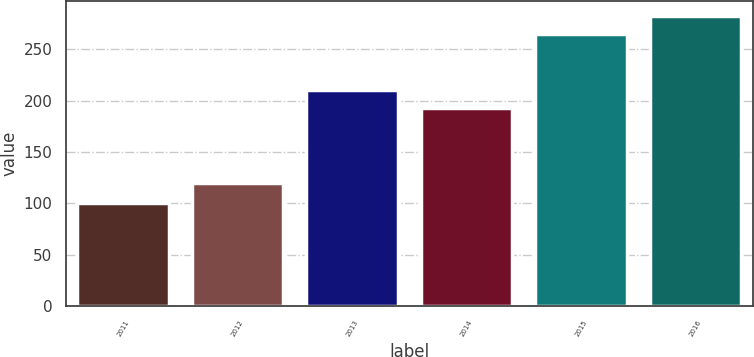Convert chart to OTSL. <chart><loc_0><loc_0><loc_500><loc_500><bar_chart><fcel>2011<fcel>2012<fcel>2013<fcel>2014<fcel>2015<fcel>2016<nl><fcel>100<fcel>119.34<fcel>210.18<fcel>192.42<fcel>264.96<fcel>282.72<nl></chart> 